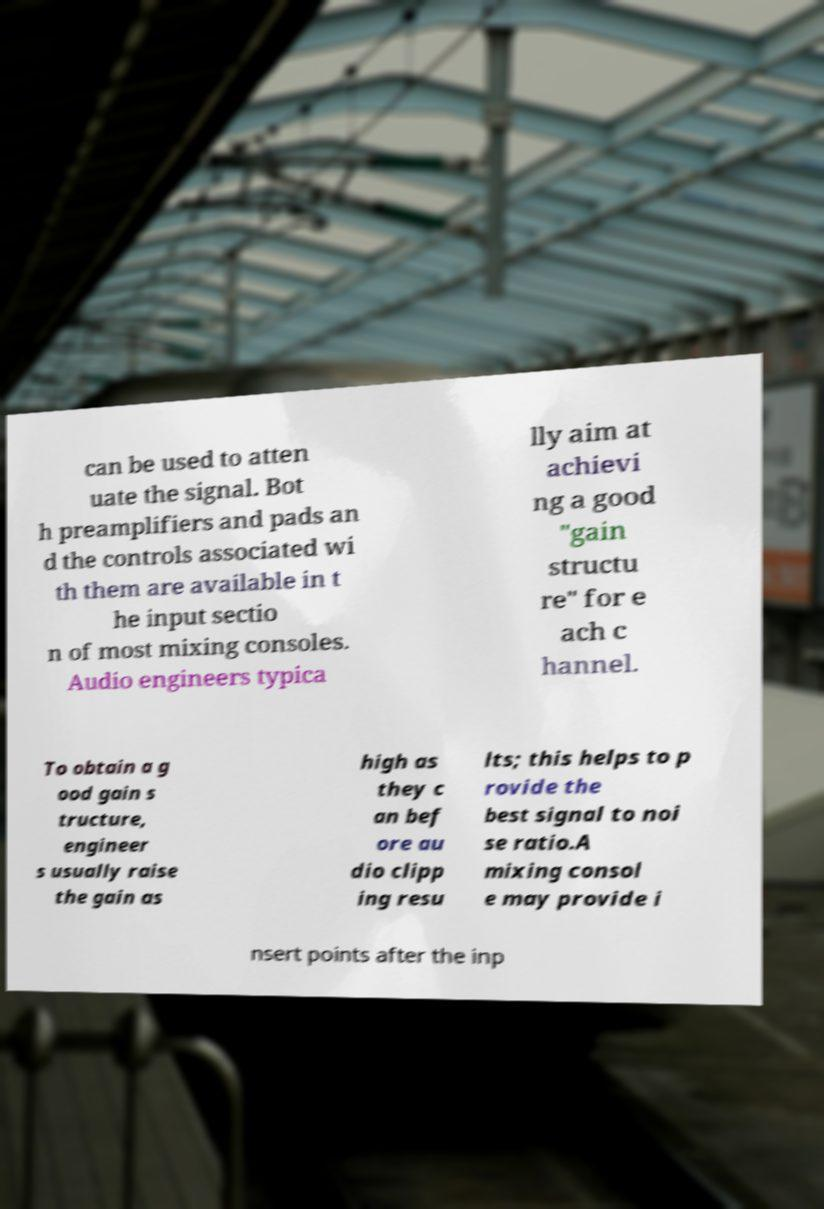Please read and relay the text visible in this image. What does it say? can be used to atten uate the signal. Bot h preamplifiers and pads an d the controls associated wi th them are available in t he input sectio n of most mixing consoles. Audio engineers typica lly aim at achievi ng a good "gain structu re" for e ach c hannel. To obtain a g ood gain s tructure, engineer s usually raise the gain as high as they c an bef ore au dio clipp ing resu lts; this helps to p rovide the best signal to noi se ratio.A mixing consol e may provide i nsert points after the inp 